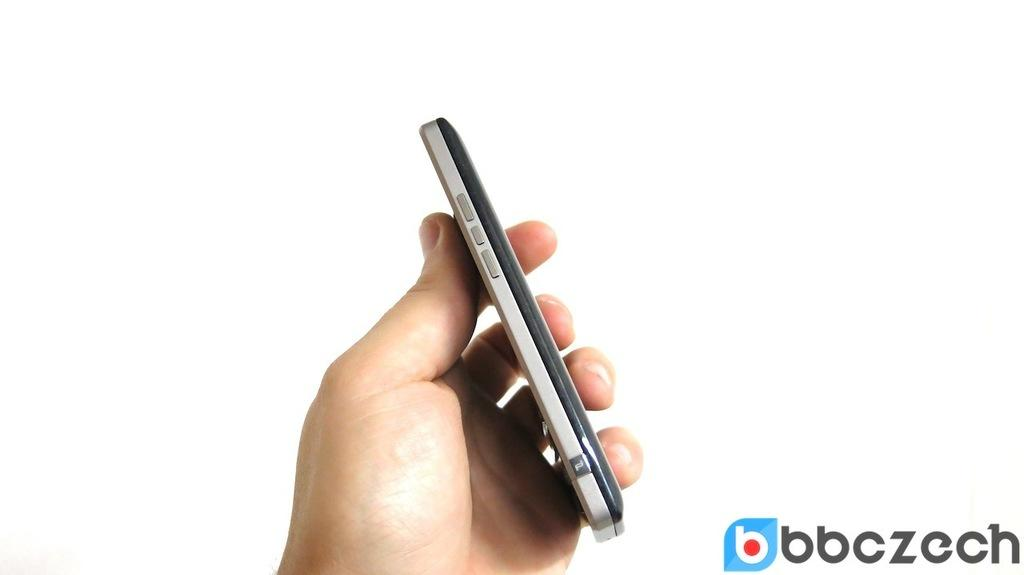What part of a person can be seen in the image? A person's hand is visible in the image. What is the person holding in their hand? The person is holding a mobile phone. What feature does the mobile phone have? The mobile phone has buttons. Where is the text located in the image? The text is in the right bottom corner of the image. What color is the background of the image? The background of the image is white. What type of bird can be seen in the image? There is no bird present in the image. What mathematical operation is being performed in the image? There is no mathematical operation or division being performed in the image. 